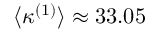Convert formula to latex. <formula><loc_0><loc_0><loc_500><loc_500>\langle \kappa ^ { ( 1 ) } \rangle \approx 3 3 . 0 5</formula> 